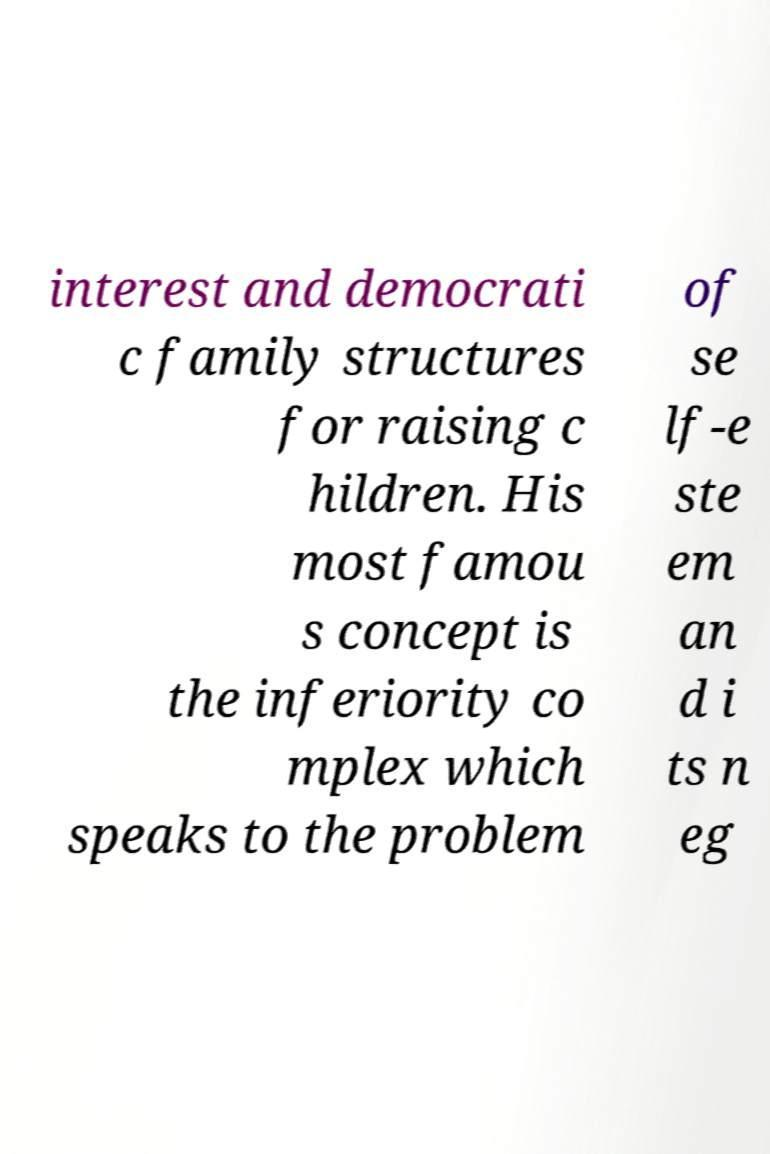Could you assist in decoding the text presented in this image and type it out clearly? interest and democrati c family structures for raising c hildren. His most famou s concept is the inferiority co mplex which speaks to the problem of se lf-e ste em an d i ts n eg 